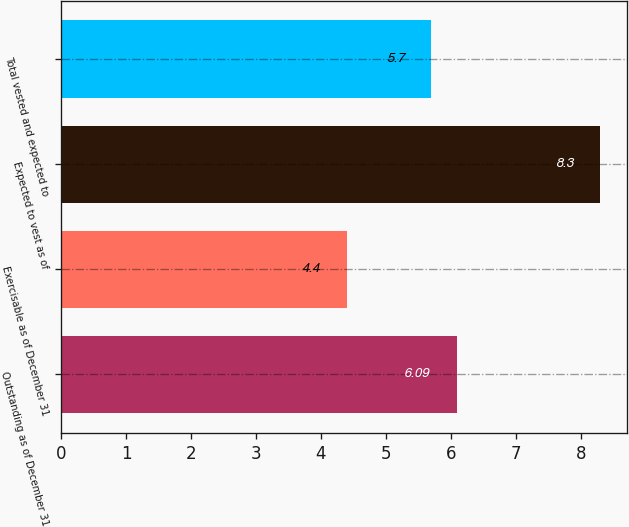<chart> <loc_0><loc_0><loc_500><loc_500><bar_chart><fcel>Outstanding as of December 31<fcel>Exercisable as of December 31<fcel>Expected to vest as of<fcel>Total vested and expected to<nl><fcel>6.09<fcel>4.4<fcel>8.3<fcel>5.7<nl></chart> 